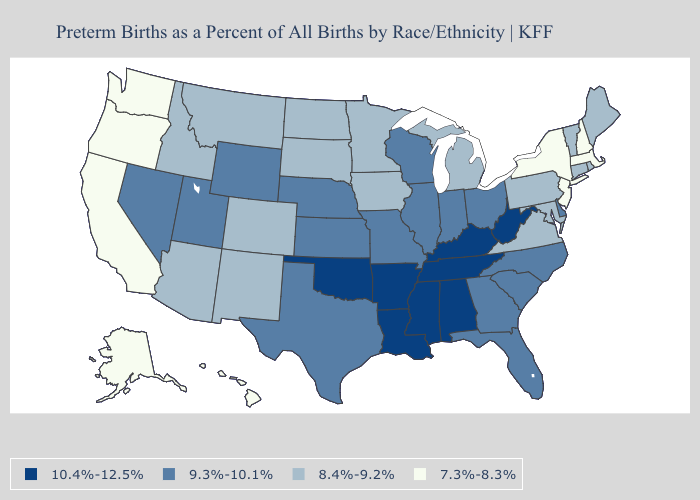Among the states that border Arizona , does California have the lowest value?
Concise answer only. Yes. Name the states that have a value in the range 10.4%-12.5%?
Write a very short answer. Alabama, Arkansas, Kentucky, Louisiana, Mississippi, Oklahoma, Tennessee, West Virginia. What is the highest value in the USA?
Short answer required. 10.4%-12.5%. How many symbols are there in the legend?
Write a very short answer. 4. What is the lowest value in states that border Connecticut?
Short answer required. 7.3%-8.3%. Which states have the lowest value in the USA?
Write a very short answer. Alaska, California, Hawaii, Massachusetts, New Hampshire, New Jersey, New York, Oregon, Washington. What is the highest value in the USA?
Concise answer only. 10.4%-12.5%. What is the value of New Jersey?
Concise answer only. 7.3%-8.3%. What is the value of Kentucky?
Give a very brief answer. 10.4%-12.5%. What is the value of Idaho?
Write a very short answer. 8.4%-9.2%. Does the map have missing data?
Give a very brief answer. No. Among the states that border Rhode Island , does Connecticut have the highest value?
Be succinct. Yes. What is the value of Ohio?
Keep it brief. 9.3%-10.1%. What is the highest value in the USA?
Answer briefly. 10.4%-12.5%. Does Michigan have the highest value in the USA?
Be succinct. No. 